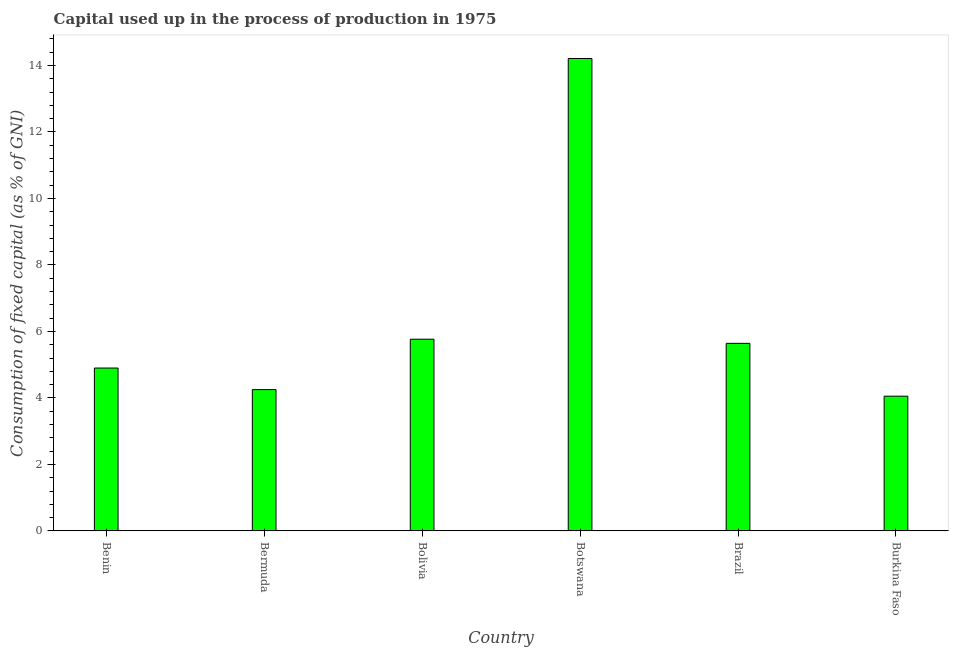What is the title of the graph?
Offer a terse response. Capital used up in the process of production in 1975. What is the label or title of the X-axis?
Keep it short and to the point. Country. What is the label or title of the Y-axis?
Offer a very short reply. Consumption of fixed capital (as % of GNI). What is the consumption of fixed capital in Benin?
Your answer should be very brief. 4.9. Across all countries, what is the maximum consumption of fixed capital?
Your answer should be very brief. 14.21. Across all countries, what is the minimum consumption of fixed capital?
Give a very brief answer. 4.05. In which country was the consumption of fixed capital maximum?
Your answer should be compact. Botswana. In which country was the consumption of fixed capital minimum?
Your answer should be very brief. Burkina Faso. What is the sum of the consumption of fixed capital?
Offer a very short reply. 38.82. What is the difference between the consumption of fixed capital in Bolivia and Burkina Faso?
Give a very brief answer. 1.71. What is the average consumption of fixed capital per country?
Provide a short and direct response. 6.47. What is the median consumption of fixed capital?
Provide a short and direct response. 5.27. In how many countries, is the consumption of fixed capital greater than 9.6 %?
Make the answer very short. 1. What is the ratio of the consumption of fixed capital in Bolivia to that in Botswana?
Ensure brevity in your answer.  0.41. Is the difference between the consumption of fixed capital in Benin and Botswana greater than the difference between any two countries?
Offer a terse response. No. What is the difference between the highest and the second highest consumption of fixed capital?
Give a very brief answer. 8.44. What is the difference between the highest and the lowest consumption of fixed capital?
Make the answer very short. 10.16. What is the difference between two consecutive major ticks on the Y-axis?
Ensure brevity in your answer.  2. Are the values on the major ticks of Y-axis written in scientific E-notation?
Offer a terse response. No. What is the Consumption of fixed capital (as % of GNI) of Benin?
Offer a terse response. 4.9. What is the Consumption of fixed capital (as % of GNI) of Bermuda?
Your answer should be compact. 4.25. What is the Consumption of fixed capital (as % of GNI) of Bolivia?
Keep it short and to the point. 5.77. What is the Consumption of fixed capital (as % of GNI) of Botswana?
Keep it short and to the point. 14.21. What is the Consumption of fixed capital (as % of GNI) in Brazil?
Give a very brief answer. 5.64. What is the Consumption of fixed capital (as % of GNI) in Burkina Faso?
Keep it short and to the point. 4.05. What is the difference between the Consumption of fixed capital (as % of GNI) in Benin and Bermuda?
Your response must be concise. 0.65. What is the difference between the Consumption of fixed capital (as % of GNI) in Benin and Bolivia?
Give a very brief answer. -0.87. What is the difference between the Consumption of fixed capital (as % of GNI) in Benin and Botswana?
Give a very brief answer. -9.31. What is the difference between the Consumption of fixed capital (as % of GNI) in Benin and Brazil?
Your answer should be very brief. -0.74. What is the difference between the Consumption of fixed capital (as % of GNI) in Benin and Burkina Faso?
Your answer should be very brief. 0.85. What is the difference between the Consumption of fixed capital (as % of GNI) in Bermuda and Bolivia?
Make the answer very short. -1.52. What is the difference between the Consumption of fixed capital (as % of GNI) in Bermuda and Botswana?
Keep it short and to the point. -9.96. What is the difference between the Consumption of fixed capital (as % of GNI) in Bermuda and Brazil?
Offer a terse response. -1.39. What is the difference between the Consumption of fixed capital (as % of GNI) in Bermuda and Burkina Faso?
Your answer should be very brief. 0.2. What is the difference between the Consumption of fixed capital (as % of GNI) in Bolivia and Botswana?
Ensure brevity in your answer.  -8.44. What is the difference between the Consumption of fixed capital (as % of GNI) in Bolivia and Brazil?
Your answer should be very brief. 0.12. What is the difference between the Consumption of fixed capital (as % of GNI) in Bolivia and Burkina Faso?
Offer a very short reply. 1.71. What is the difference between the Consumption of fixed capital (as % of GNI) in Botswana and Brazil?
Your answer should be compact. 8.57. What is the difference between the Consumption of fixed capital (as % of GNI) in Botswana and Burkina Faso?
Your response must be concise. 10.16. What is the difference between the Consumption of fixed capital (as % of GNI) in Brazil and Burkina Faso?
Ensure brevity in your answer.  1.59. What is the ratio of the Consumption of fixed capital (as % of GNI) in Benin to that in Bermuda?
Provide a succinct answer. 1.15. What is the ratio of the Consumption of fixed capital (as % of GNI) in Benin to that in Bolivia?
Your response must be concise. 0.85. What is the ratio of the Consumption of fixed capital (as % of GNI) in Benin to that in Botswana?
Keep it short and to the point. 0.34. What is the ratio of the Consumption of fixed capital (as % of GNI) in Benin to that in Brazil?
Ensure brevity in your answer.  0.87. What is the ratio of the Consumption of fixed capital (as % of GNI) in Benin to that in Burkina Faso?
Offer a terse response. 1.21. What is the ratio of the Consumption of fixed capital (as % of GNI) in Bermuda to that in Bolivia?
Your answer should be compact. 0.74. What is the ratio of the Consumption of fixed capital (as % of GNI) in Bermuda to that in Botswana?
Ensure brevity in your answer.  0.3. What is the ratio of the Consumption of fixed capital (as % of GNI) in Bermuda to that in Brazil?
Ensure brevity in your answer.  0.75. What is the ratio of the Consumption of fixed capital (as % of GNI) in Bermuda to that in Burkina Faso?
Provide a short and direct response. 1.05. What is the ratio of the Consumption of fixed capital (as % of GNI) in Bolivia to that in Botswana?
Provide a short and direct response. 0.41. What is the ratio of the Consumption of fixed capital (as % of GNI) in Bolivia to that in Brazil?
Ensure brevity in your answer.  1.02. What is the ratio of the Consumption of fixed capital (as % of GNI) in Bolivia to that in Burkina Faso?
Your answer should be very brief. 1.42. What is the ratio of the Consumption of fixed capital (as % of GNI) in Botswana to that in Brazil?
Give a very brief answer. 2.52. What is the ratio of the Consumption of fixed capital (as % of GNI) in Botswana to that in Burkina Faso?
Provide a short and direct response. 3.51. What is the ratio of the Consumption of fixed capital (as % of GNI) in Brazil to that in Burkina Faso?
Keep it short and to the point. 1.39. 